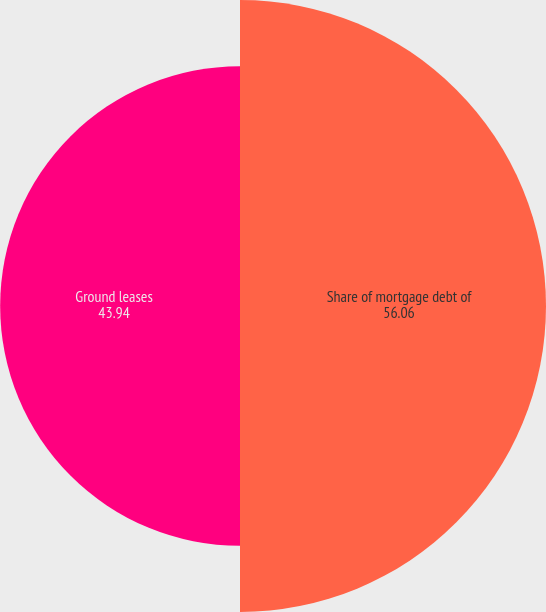Convert chart. <chart><loc_0><loc_0><loc_500><loc_500><pie_chart><fcel>Share of mortgage debt of<fcel>Ground leases<nl><fcel>56.06%<fcel>43.94%<nl></chart> 